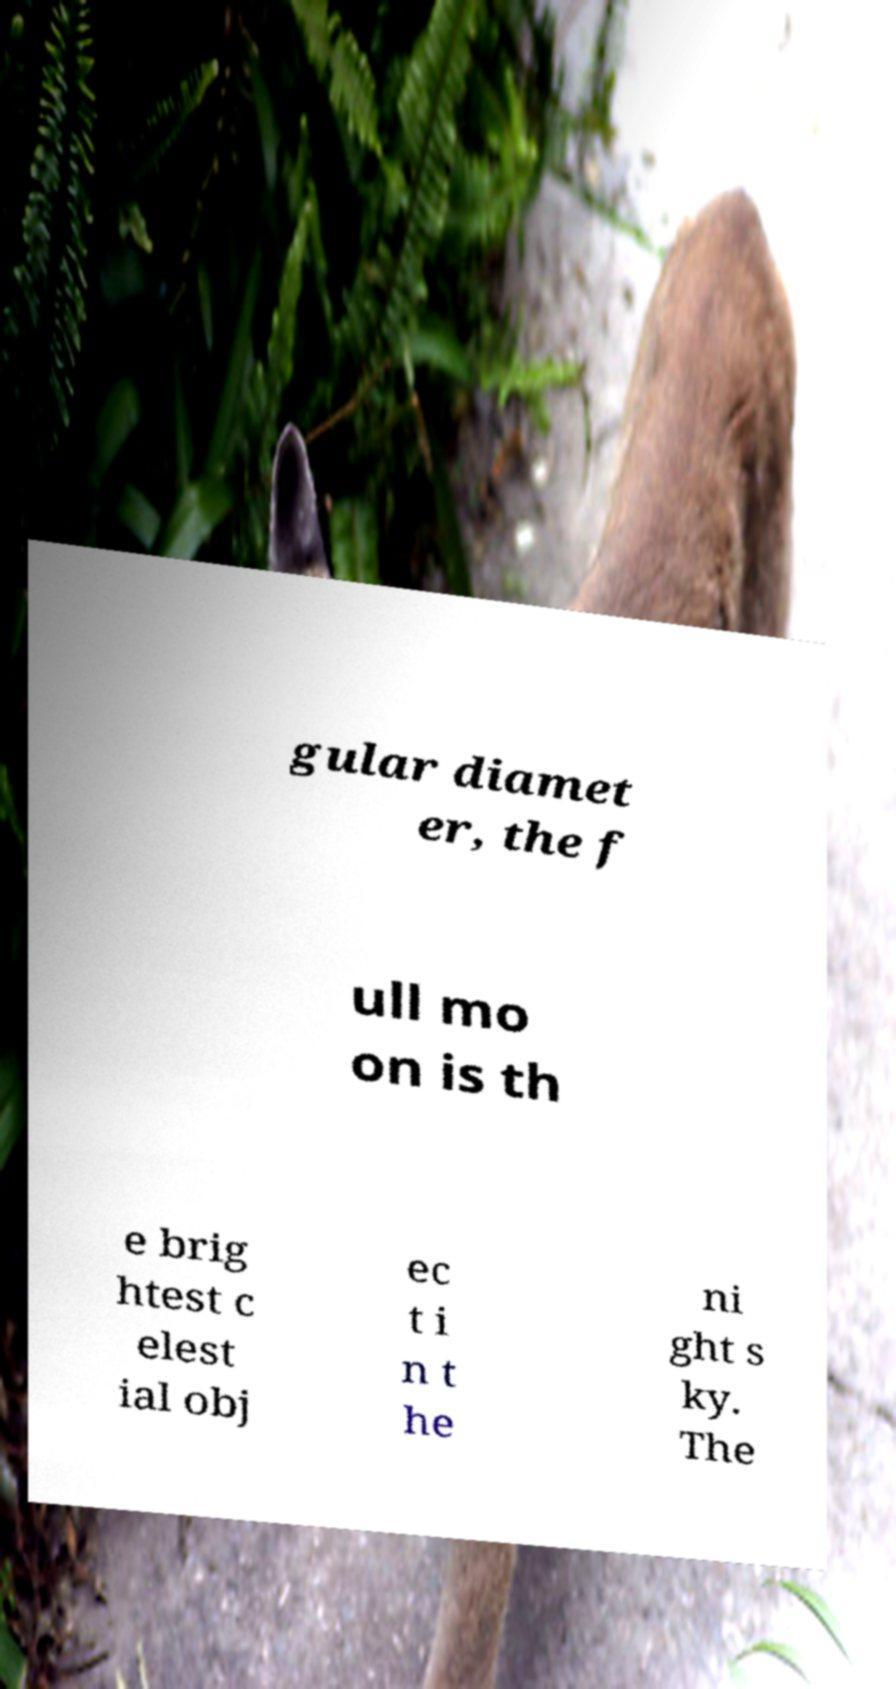Can you accurately transcribe the text from the provided image for me? gular diamet er, the f ull mo on is th e brig htest c elest ial obj ec t i n t he ni ght s ky. The 